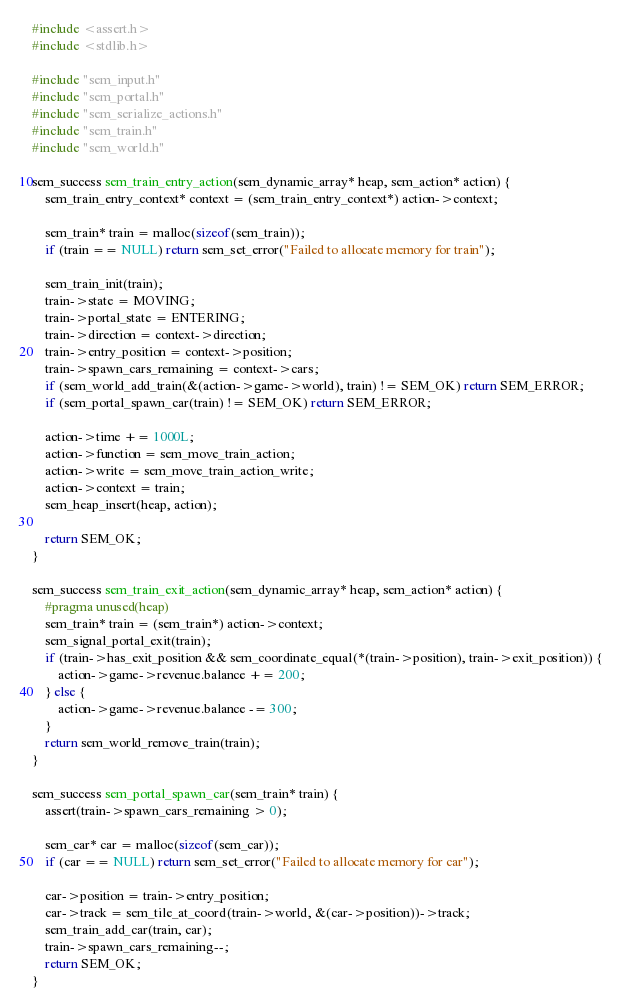<code> <loc_0><loc_0><loc_500><loc_500><_C_>#include <assert.h>
#include <stdlib.h>

#include "sem_input.h"
#include "sem_portal.h"
#include "sem_serialize_actions.h"
#include "sem_train.h"
#include "sem_world.h"

sem_success sem_train_entry_action(sem_dynamic_array* heap, sem_action* action) {
	sem_train_entry_context* context = (sem_train_entry_context*) action->context;
	
	sem_train* train = malloc(sizeof(sem_train));
	if (train == NULL) return sem_set_error("Failed to allocate memory for train");

	sem_train_init(train);
	train->state = MOVING;
	train->portal_state = ENTERING;
	train->direction = context->direction;
	train->entry_position = context->position;
	train->spawn_cars_remaining = context->cars;
	if (sem_world_add_train(&(action->game->world), train) != SEM_OK) return SEM_ERROR;
	if (sem_portal_spawn_car(train) != SEM_OK) return SEM_ERROR;

	action->time += 1000L;
	action->function = sem_move_train_action;
	action->write = sem_move_train_action_write;
	action->context = train;
	sem_heap_insert(heap, action);

	return SEM_OK;
}

sem_success sem_train_exit_action(sem_dynamic_array* heap, sem_action* action) {
	#pragma unused(heap)
	sem_train* train = (sem_train*) action->context;
	sem_signal_portal_exit(train);
	if (train->has_exit_position && sem_coordinate_equal(*(train->position), train->exit_position)) {
		action->game->revenue.balance += 200;
	} else {
		action->game->revenue.balance -= 300;
	}
	return sem_world_remove_train(train);	
}

sem_success sem_portal_spawn_car(sem_train* train) {
	assert(train->spawn_cars_remaining > 0);

	sem_car* car = malloc(sizeof(sem_car));
	if (car == NULL) return sem_set_error("Failed to allocate memory for car");

	car->position = train->entry_position;
	car->track = sem_tile_at_coord(train->world, &(car->position))->track;
	sem_train_add_car(train, car);
	train->spawn_cars_remaining--;
	return SEM_OK;
}
</code> 